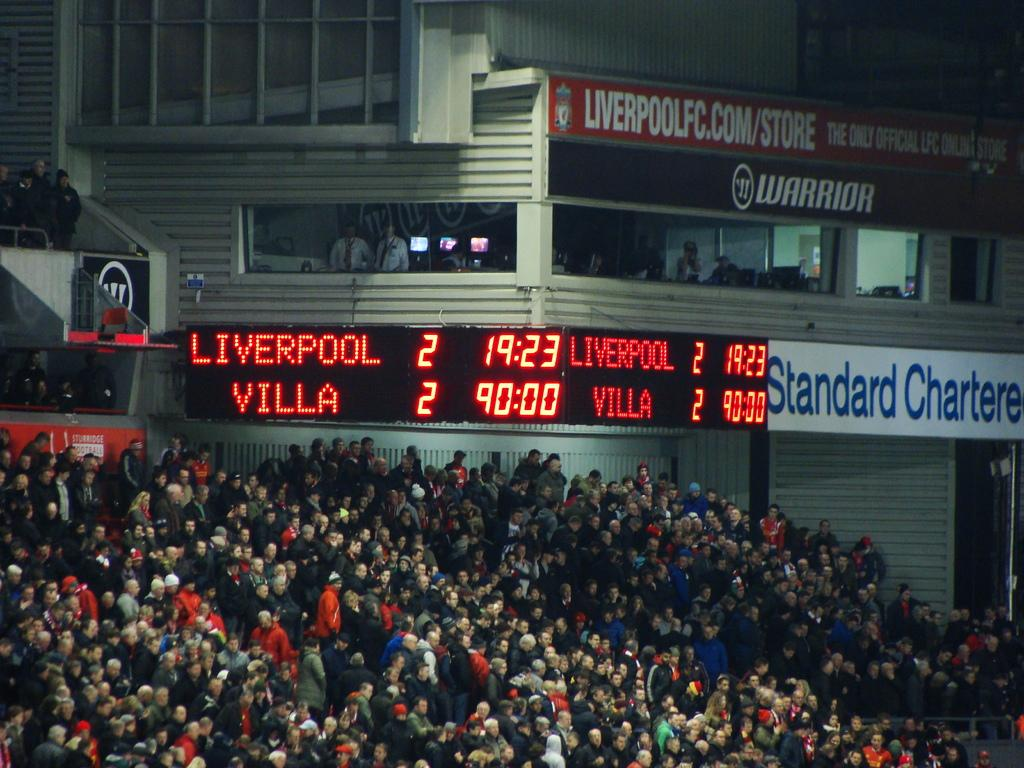Provide a one-sentence caption for the provided image. Stadium full of spectators at a sporting event featuring Liverpool and Villa with a tied score. 